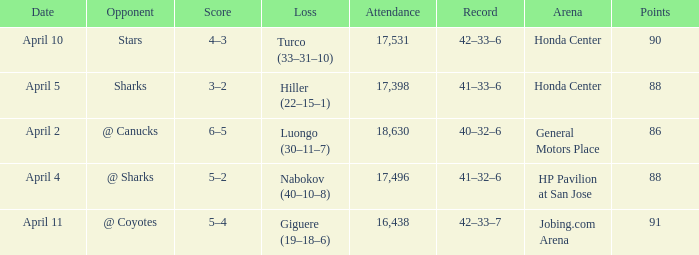On what date was the Record 41–32–6? April 4. 